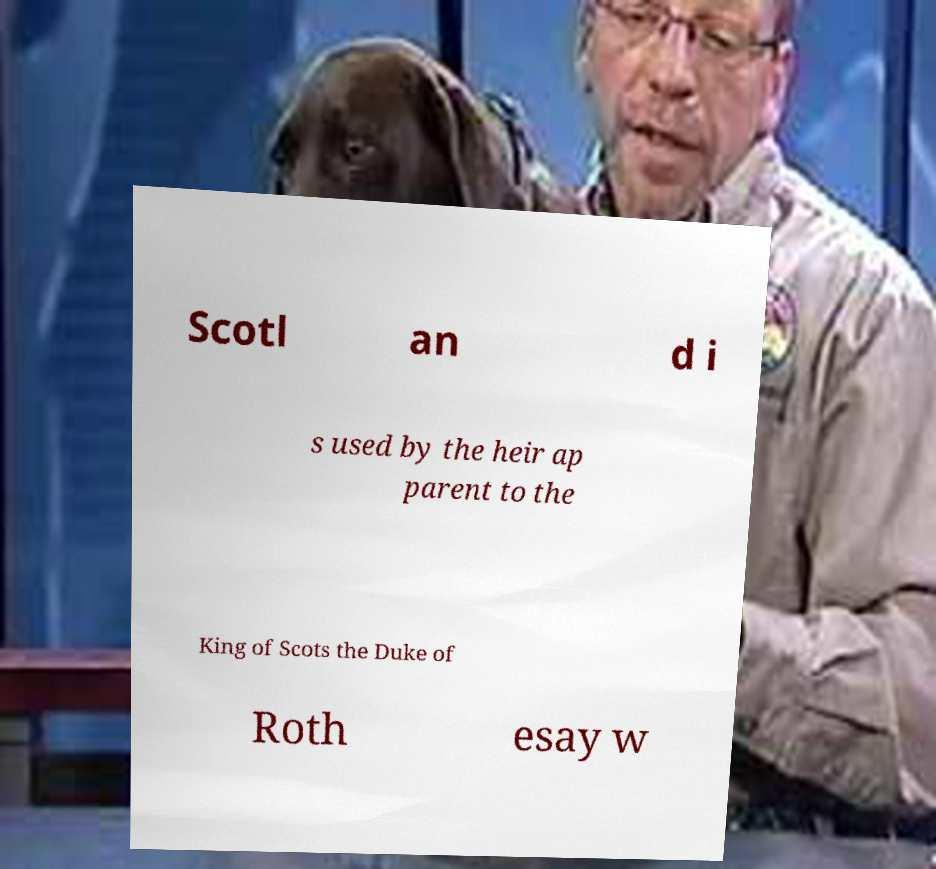Could you extract and type out the text from this image? Scotl an d i s used by the heir ap parent to the King of Scots the Duke of Roth esay w 